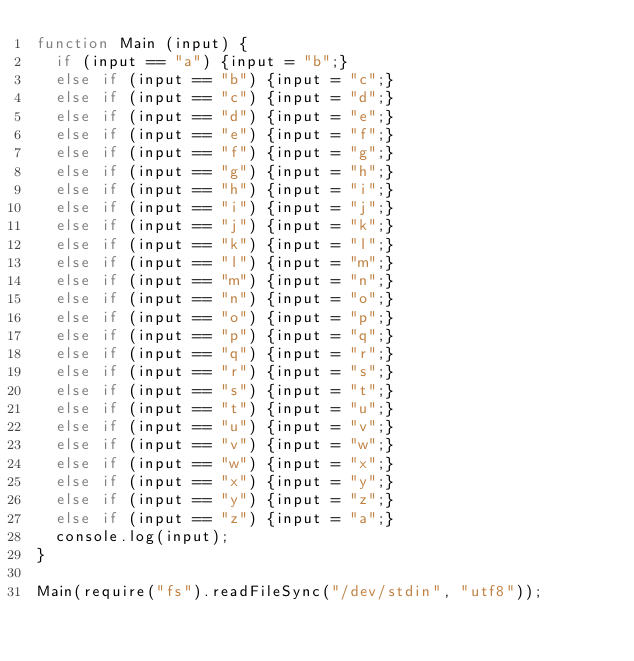<code> <loc_0><loc_0><loc_500><loc_500><_JavaScript_>function Main (input) {
  if (input == "a") {input = "b";}
  else if (input == "b") {input = "c";}
  else if (input == "c") {input = "d";}
  else if (input == "d") {input = "e";}
  else if (input == "e") {input = "f";}
  else if (input == "f") {input = "g";}
  else if (input == "g") {input = "h";}
  else if (input == "h") {input = "i";}
  else if (input == "i") {input = "j";}
  else if (input == "j") {input = "k";}
  else if (input == "k") {input = "l";}
  else if (input == "l") {input = "m";}
  else if (input == "m") {input = "n";}
  else if (input == "n") {input = "o";}
  else if (input == "o") {input = "p";}
  else if (input == "p") {input = "q";}
  else if (input == "q") {input = "r";}
  else if (input == "r") {input = "s";}
  else if (input == "s") {input = "t";}
  else if (input == "t") {input = "u";}
  else if (input == "u") {input = "v";}
  else if (input == "v") {input = "w";}
  else if (input == "w") {input = "x";}
  else if (input == "x") {input = "y";}
  else if (input == "y") {input = "z";}
  else if (input == "z") {input = "a";}
  console.log(input);
}

Main(require("fs").readFileSync("/dev/stdin", "utf8"));</code> 